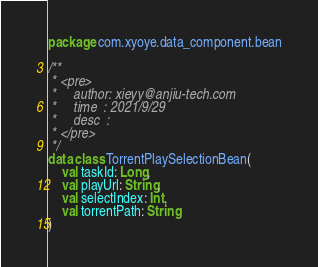Convert code to text. <code><loc_0><loc_0><loc_500><loc_500><_Kotlin_>package com.xyoye.data_component.bean

/**
 * <pre>
 *     author: xieyy@anjiu-tech.com
 *     time  : 2021/9/29
 *     desc  :
 * </pre>
 */
data class TorrentPlaySelectionBean(
    val taskId: Long,
    val playUrl: String,
    val selectIndex: Int,
    val torrentPath: String
)</code> 